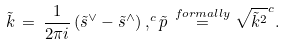<formula> <loc_0><loc_0><loc_500><loc_500>\tilde { k } \, = \, \frac { 1 } { 2 \pi i } \, ( \tilde { s } ^ { \vee } - \tilde { s } ^ { \wedge } ) \, , ^ { c } \tilde { p } \, \stackrel { f o r m a l l y } { = } \sqrt { \tilde { k } ^ { 2 } } ^ { c } .</formula> 